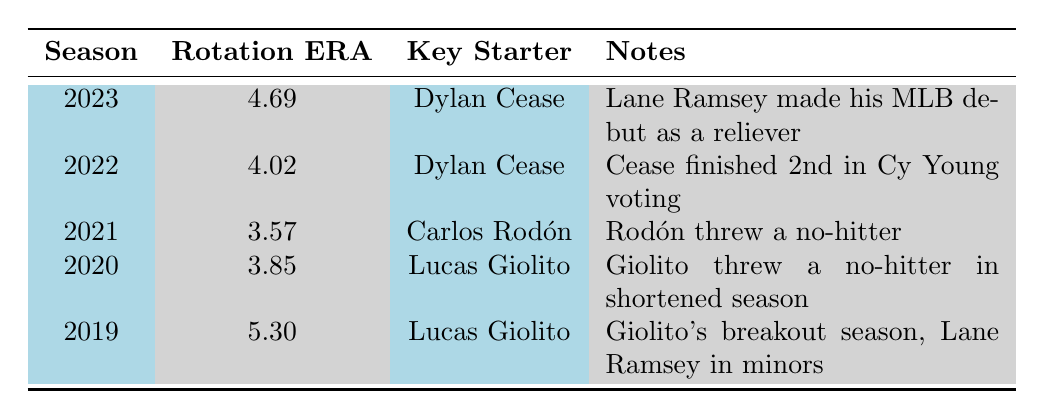What was the Chicago White Sox starting rotation ERA in 2020? By looking at the "Rotation ERA" column for the year 2020, we see the value listed is 3.85.
Answer: 3.85 Who was the key starter for the White Sox in 2021? Referring to the "Key Starter" column for the year 2021, it shows Carlos Rodón as the key starter.
Answer: Carlos Rodón In which year did Dylan Cease finish 2nd in Cy Young voting? From the "Notes" column for the season of 2022, it mentions that Cease finished 2nd in Cy Young voting.
Answer: 2022 What is the average rotation ERA over the last five seasons? Adding up the Rotation ERAs: 4.69 + 4.02 + 3.57 + 3.85 + 5.30 = 21.43. Dividing this by 5 gives an average of 4.286.
Answer: 4.286 Did the rotation ERA improve from 2019 to 2021? Comparing the Rotation ERAs: in 2019 the ERA was 5.30 and in 2021 it was 3.57. Since 3.57 is lower than 5.30, the ERA improved.
Answer: Yes Which season had the highest Rotation ERA? By examining all the Rotation ERA values, 5.30 in 2019 is the highest among the listed seasons.
Answer: 2019 What notable event is associated with Lucas Giolito in the 2020 season? Referring to the "Notes" column for 2020, it states that Giolito threw a no-hitter during that shortened season.
Answer: Giolito threw a no-hitter Which season has Lane Ramsey mentioned in the notes, and what was his role? Looking at the notes for 2023, it states that Lane Ramsey made his MLB debut as a reliever.
Answer: 2023, as a reliever How much higher was the rotation ERA in 2023 compared to 2021? The rotation ERA for 2023 is 4.69 and for 2021 it is 3.57. Subtracting gives 4.69 - 3.57 = 1.12.
Answer: 1.12 